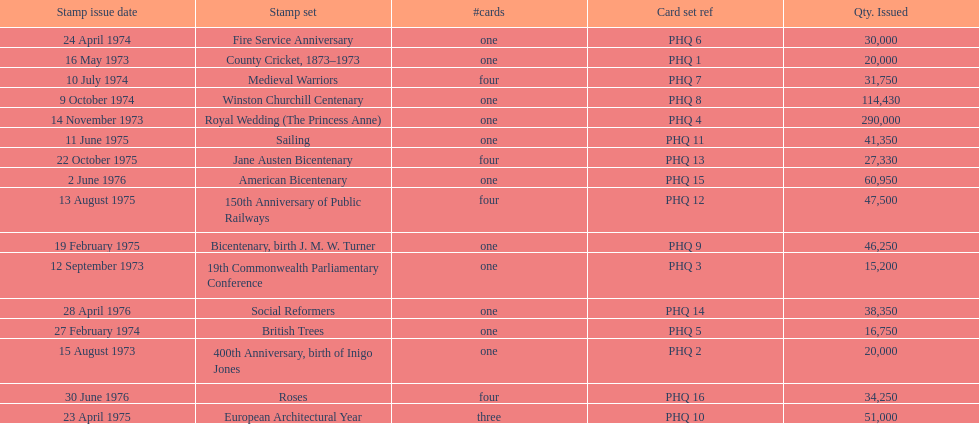Which year had the most stamps issued? 1973. 